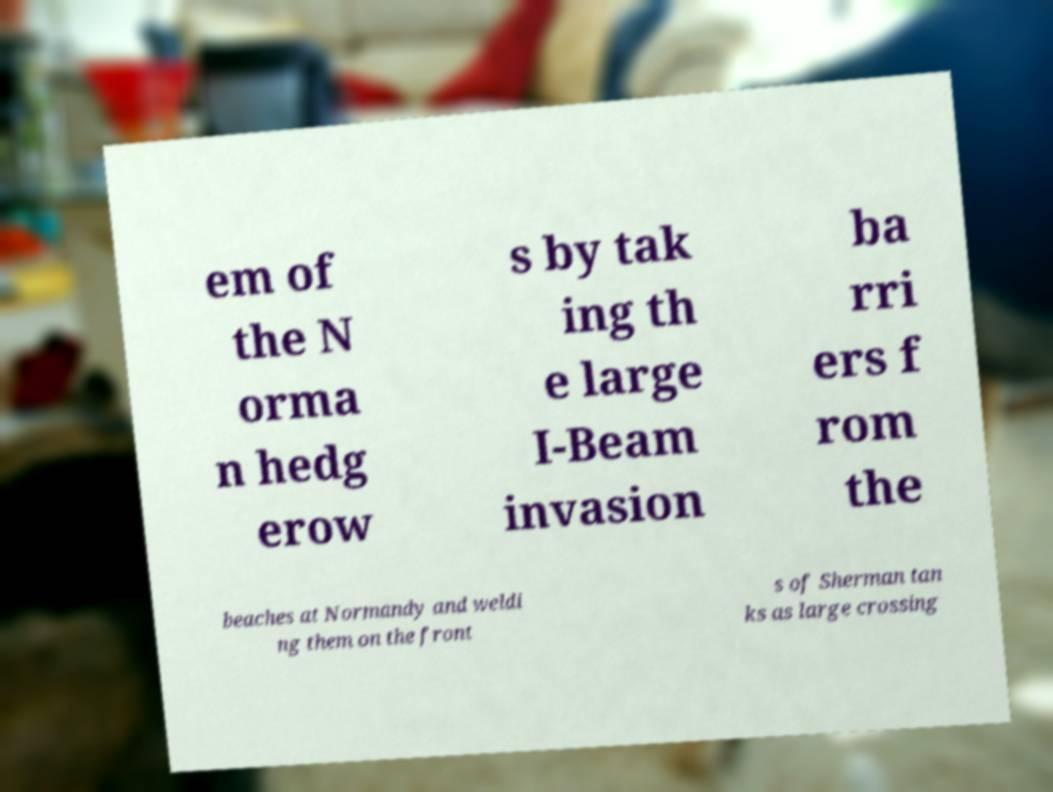Please identify and transcribe the text found in this image. em of the N orma n hedg erow s by tak ing th e large I-Beam invasion ba rri ers f rom the beaches at Normandy and weldi ng them on the front s of Sherman tan ks as large crossing 